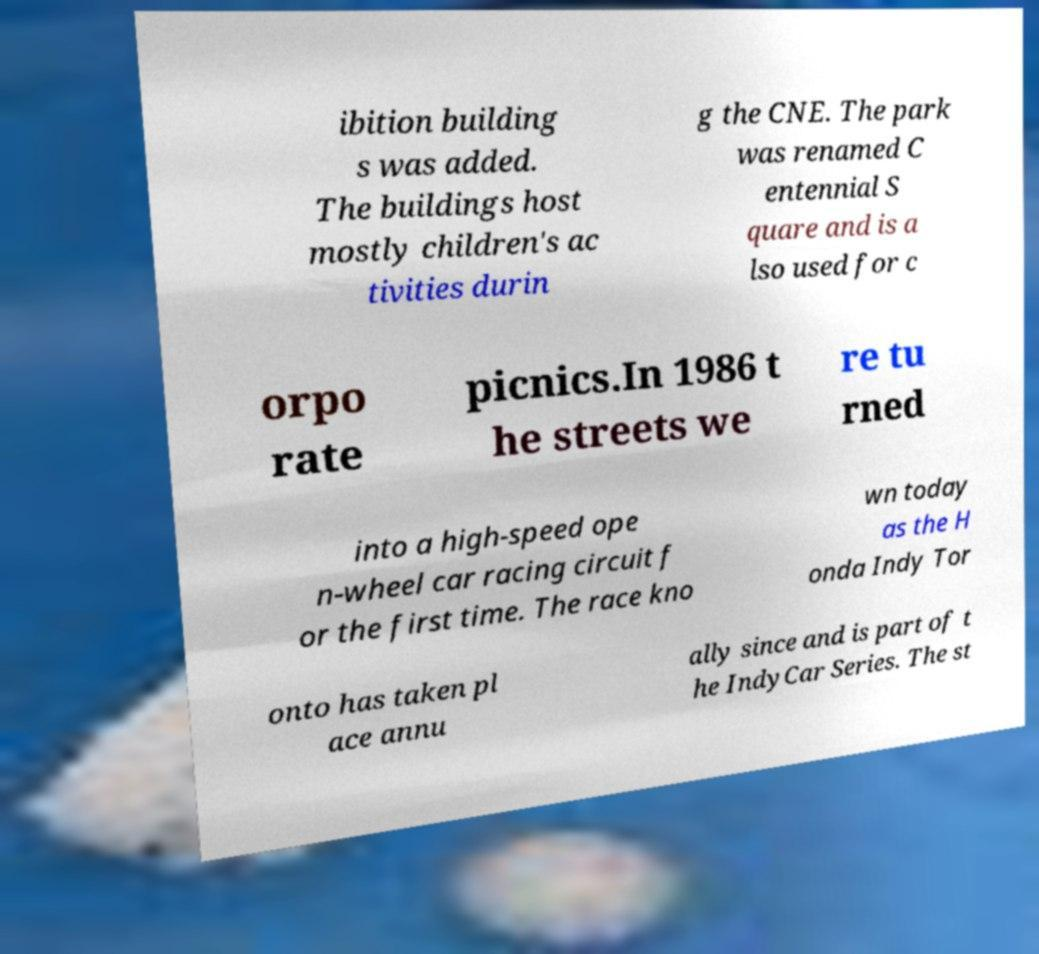For documentation purposes, I need the text within this image transcribed. Could you provide that? ibition building s was added. The buildings host mostly children's ac tivities durin g the CNE. The park was renamed C entennial S quare and is a lso used for c orpo rate picnics.In 1986 t he streets we re tu rned into a high-speed ope n-wheel car racing circuit f or the first time. The race kno wn today as the H onda Indy Tor onto has taken pl ace annu ally since and is part of t he IndyCar Series. The st 